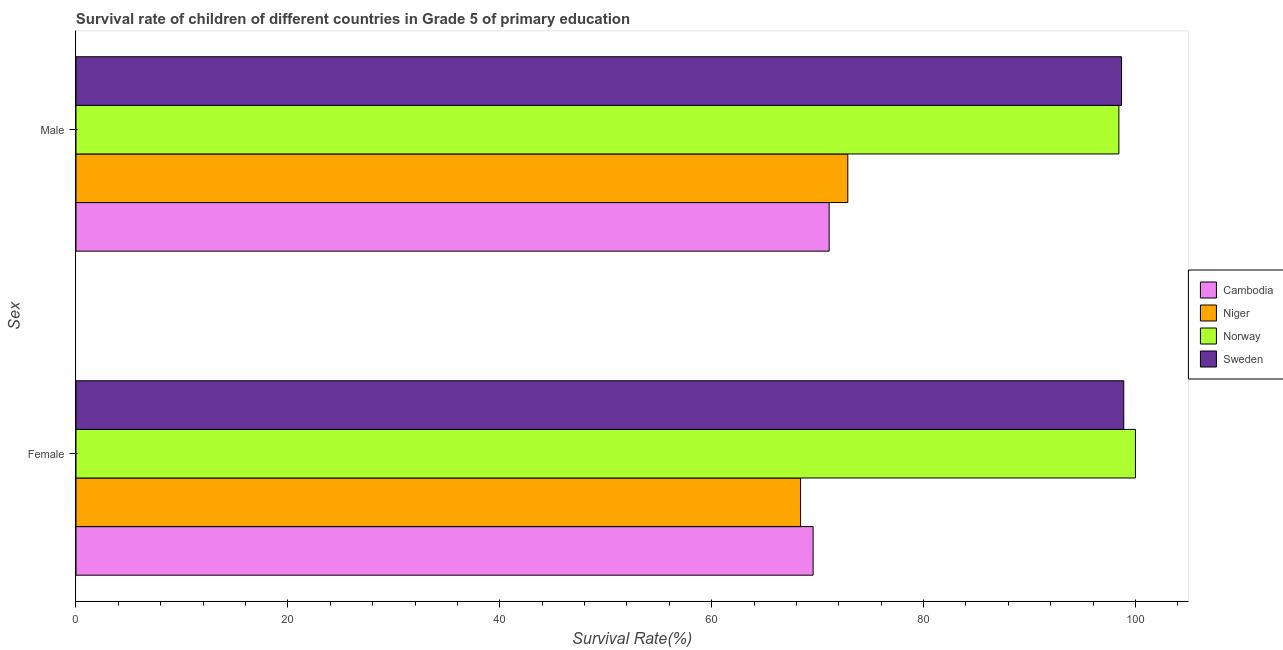How many different coloured bars are there?
Offer a terse response. 4. How many groups of bars are there?
Offer a terse response. 2. Are the number of bars per tick equal to the number of legend labels?
Ensure brevity in your answer.  Yes. Are the number of bars on each tick of the Y-axis equal?
Your answer should be compact. Yes. What is the label of the 1st group of bars from the top?
Make the answer very short. Male. Across all countries, what is the maximum survival rate of male students in primary education?
Your response must be concise. 98.69. Across all countries, what is the minimum survival rate of female students in primary education?
Your answer should be compact. 68.39. In which country was the survival rate of male students in primary education minimum?
Offer a very short reply. Cambodia. What is the total survival rate of male students in primary education in the graph?
Your response must be concise. 341.07. What is the difference between the survival rate of female students in primary education in Cambodia and that in Sweden?
Your response must be concise. -29.32. What is the difference between the survival rate of male students in primary education in Niger and the survival rate of female students in primary education in Sweden?
Make the answer very short. -26.05. What is the average survival rate of female students in primary education per country?
Ensure brevity in your answer.  84.22. What is the difference between the survival rate of female students in primary education and survival rate of male students in primary education in Sweden?
Offer a terse response. 0.21. What is the ratio of the survival rate of female students in primary education in Cambodia to that in Niger?
Provide a short and direct response. 1.02. Is the survival rate of female students in primary education in Cambodia less than that in Sweden?
Provide a succinct answer. Yes. In how many countries, is the survival rate of male students in primary education greater than the average survival rate of male students in primary education taken over all countries?
Your answer should be compact. 2. What does the 4th bar from the top in Female represents?
Offer a very short reply. Cambodia. What does the 4th bar from the bottom in Female represents?
Keep it short and to the point. Sweden. How many bars are there?
Ensure brevity in your answer.  8. Are all the bars in the graph horizontal?
Provide a succinct answer. Yes. How many countries are there in the graph?
Make the answer very short. 4. What is the difference between two consecutive major ticks on the X-axis?
Your answer should be compact. 20. Are the values on the major ticks of X-axis written in scientific E-notation?
Ensure brevity in your answer.  No. How many legend labels are there?
Provide a short and direct response. 4. What is the title of the graph?
Your answer should be compact. Survival rate of children of different countries in Grade 5 of primary education. Does "Turks and Caicos Islands" appear as one of the legend labels in the graph?
Make the answer very short. No. What is the label or title of the X-axis?
Provide a succinct answer. Survival Rate(%). What is the label or title of the Y-axis?
Your response must be concise. Sex. What is the Survival Rate(%) of Cambodia in Female?
Ensure brevity in your answer.  69.58. What is the Survival Rate(%) of Niger in Female?
Ensure brevity in your answer.  68.39. What is the Survival Rate(%) of Sweden in Female?
Your answer should be compact. 98.9. What is the Survival Rate(%) of Cambodia in Male?
Provide a short and direct response. 71.09. What is the Survival Rate(%) in Niger in Male?
Your answer should be compact. 72.85. What is the Survival Rate(%) of Norway in Male?
Your response must be concise. 98.44. What is the Survival Rate(%) in Sweden in Male?
Provide a succinct answer. 98.69. Across all Sex, what is the maximum Survival Rate(%) of Cambodia?
Offer a terse response. 71.09. Across all Sex, what is the maximum Survival Rate(%) of Niger?
Your answer should be compact. 72.85. Across all Sex, what is the maximum Survival Rate(%) of Norway?
Your answer should be compact. 100. Across all Sex, what is the maximum Survival Rate(%) of Sweden?
Give a very brief answer. 98.9. Across all Sex, what is the minimum Survival Rate(%) in Cambodia?
Keep it short and to the point. 69.58. Across all Sex, what is the minimum Survival Rate(%) of Niger?
Provide a short and direct response. 68.39. Across all Sex, what is the minimum Survival Rate(%) in Norway?
Provide a succinct answer. 98.44. Across all Sex, what is the minimum Survival Rate(%) in Sweden?
Provide a short and direct response. 98.69. What is the total Survival Rate(%) of Cambodia in the graph?
Offer a terse response. 140.67. What is the total Survival Rate(%) in Niger in the graph?
Your answer should be very brief. 141.24. What is the total Survival Rate(%) in Norway in the graph?
Give a very brief answer. 198.44. What is the total Survival Rate(%) in Sweden in the graph?
Offer a very short reply. 197.59. What is the difference between the Survival Rate(%) of Cambodia in Female and that in Male?
Provide a succinct answer. -1.52. What is the difference between the Survival Rate(%) in Niger in Female and that in Male?
Make the answer very short. -4.46. What is the difference between the Survival Rate(%) in Norway in Female and that in Male?
Your answer should be compact. 1.56. What is the difference between the Survival Rate(%) in Sweden in Female and that in Male?
Offer a very short reply. 0.21. What is the difference between the Survival Rate(%) in Cambodia in Female and the Survival Rate(%) in Niger in Male?
Offer a terse response. -3.27. What is the difference between the Survival Rate(%) in Cambodia in Female and the Survival Rate(%) in Norway in Male?
Offer a very short reply. -28.86. What is the difference between the Survival Rate(%) in Cambodia in Female and the Survival Rate(%) in Sweden in Male?
Ensure brevity in your answer.  -29.11. What is the difference between the Survival Rate(%) in Niger in Female and the Survival Rate(%) in Norway in Male?
Provide a short and direct response. -30.04. What is the difference between the Survival Rate(%) of Niger in Female and the Survival Rate(%) of Sweden in Male?
Your answer should be very brief. -30.29. What is the difference between the Survival Rate(%) in Norway in Female and the Survival Rate(%) in Sweden in Male?
Make the answer very short. 1.31. What is the average Survival Rate(%) of Cambodia per Sex?
Your answer should be compact. 70.33. What is the average Survival Rate(%) in Niger per Sex?
Give a very brief answer. 70.62. What is the average Survival Rate(%) of Norway per Sex?
Keep it short and to the point. 99.22. What is the average Survival Rate(%) of Sweden per Sex?
Your answer should be compact. 98.79. What is the difference between the Survival Rate(%) in Cambodia and Survival Rate(%) in Niger in Female?
Provide a succinct answer. 1.18. What is the difference between the Survival Rate(%) in Cambodia and Survival Rate(%) in Norway in Female?
Make the answer very short. -30.42. What is the difference between the Survival Rate(%) of Cambodia and Survival Rate(%) of Sweden in Female?
Your answer should be compact. -29.32. What is the difference between the Survival Rate(%) in Niger and Survival Rate(%) in Norway in Female?
Keep it short and to the point. -31.61. What is the difference between the Survival Rate(%) in Niger and Survival Rate(%) in Sweden in Female?
Ensure brevity in your answer.  -30.5. What is the difference between the Survival Rate(%) of Norway and Survival Rate(%) of Sweden in Female?
Provide a succinct answer. 1.1. What is the difference between the Survival Rate(%) in Cambodia and Survival Rate(%) in Niger in Male?
Your response must be concise. -1.76. What is the difference between the Survival Rate(%) in Cambodia and Survival Rate(%) in Norway in Male?
Ensure brevity in your answer.  -27.35. What is the difference between the Survival Rate(%) of Cambodia and Survival Rate(%) of Sweden in Male?
Offer a very short reply. -27.6. What is the difference between the Survival Rate(%) in Niger and Survival Rate(%) in Norway in Male?
Keep it short and to the point. -25.59. What is the difference between the Survival Rate(%) of Niger and Survival Rate(%) of Sweden in Male?
Provide a short and direct response. -25.84. What is the difference between the Survival Rate(%) of Norway and Survival Rate(%) of Sweden in Male?
Make the answer very short. -0.25. What is the ratio of the Survival Rate(%) of Cambodia in Female to that in Male?
Ensure brevity in your answer.  0.98. What is the ratio of the Survival Rate(%) in Niger in Female to that in Male?
Provide a succinct answer. 0.94. What is the ratio of the Survival Rate(%) in Norway in Female to that in Male?
Offer a very short reply. 1.02. What is the difference between the highest and the second highest Survival Rate(%) of Cambodia?
Offer a very short reply. 1.52. What is the difference between the highest and the second highest Survival Rate(%) of Niger?
Ensure brevity in your answer.  4.46. What is the difference between the highest and the second highest Survival Rate(%) in Norway?
Make the answer very short. 1.56. What is the difference between the highest and the second highest Survival Rate(%) of Sweden?
Give a very brief answer. 0.21. What is the difference between the highest and the lowest Survival Rate(%) of Cambodia?
Your response must be concise. 1.52. What is the difference between the highest and the lowest Survival Rate(%) of Niger?
Ensure brevity in your answer.  4.46. What is the difference between the highest and the lowest Survival Rate(%) in Norway?
Your answer should be very brief. 1.56. What is the difference between the highest and the lowest Survival Rate(%) of Sweden?
Provide a succinct answer. 0.21. 